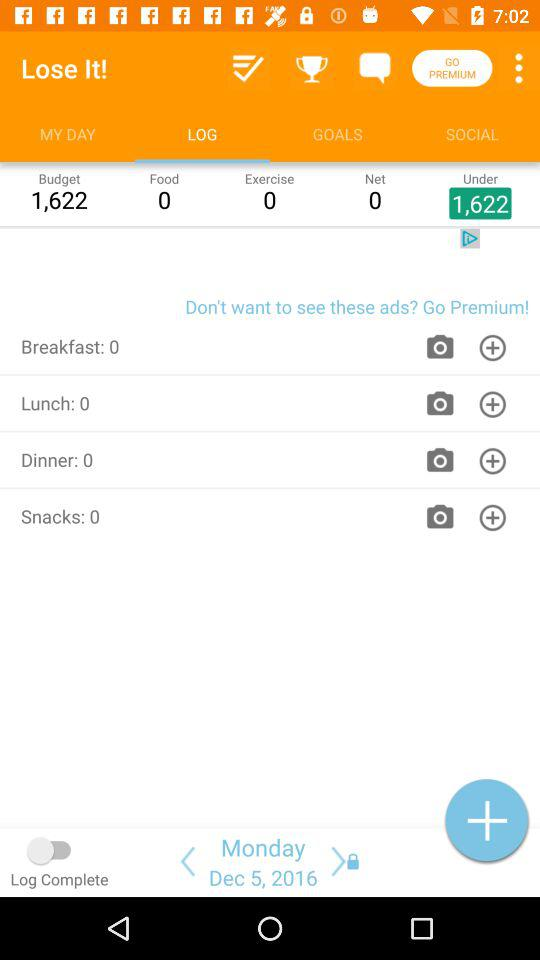How many calories do I have left for the day?
Answer the question using a single word or phrase. 1,622 